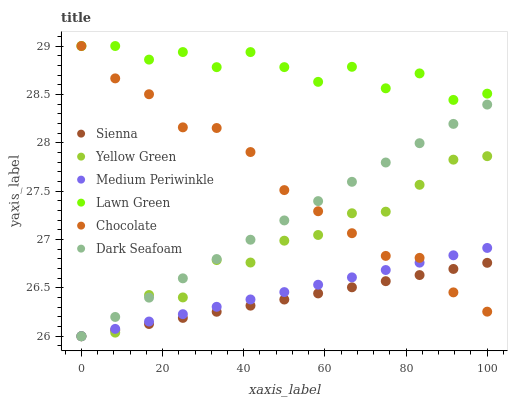Does Sienna have the minimum area under the curve?
Answer yes or no. Yes. Does Lawn Green have the maximum area under the curve?
Answer yes or no. Yes. Does Yellow Green have the minimum area under the curve?
Answer yes or no. No. Does Yellow Green have the maximum area under the curve?
Answer yes or no. No. Is Dark Seafoam the smoothest?
Answer yes or no. Yes. Is Lawn Green the roughest?
Answer yes or no. Yes. Is Yellow Green the smoothest?
Answer yes or no. No. Is Yellow Green the roughest?
Answer yes or no. No. Does Yellow Green have the lowest value?
Answer yes or no. Yes. Does Chocolate have the lowest value?
Answer yes or no. No. Does Chocolate have the highest value?
Answer yes or no. Yes. Does Yellow Green have the highest value?
Answer yes or no. No. Is Medium Periwinkle less than Lawn Green?
Answer yes or no. Yes. Is Lawn Green greater than Medium Periwinkle?
Answer yes or no. Yes. Does Dark Seafoam intersect Yellow Green?
Answer yes or no. Yes. Is Dark Seafoam less than Yellow Green?
Answer yes or no. No. Is Dark Seafoam greater than Yellow Green?
Answer yes or no. No. Does Medium Periwinkle intersect Lawn Green?
Answer yes or no. No. 